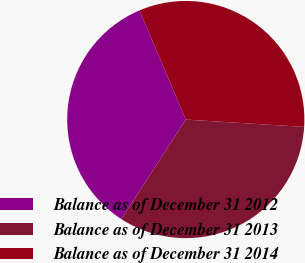Convert chart to OTSL. <chart><loc_0><loc_0><loc_500><loc_500><pie_chart><fcel>Balance as of December 31 2012<fcel>Balance as of December 31 2013<fcel>Balance as of December 31 2014<nl><fcel>34.48%<fcel>33.16%<fcel>32.36%<nl></chart> 